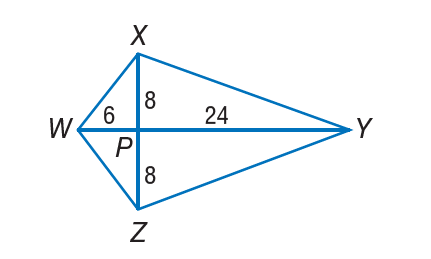Answer the mathemtical geometry problem and directly provide the correct option letter.
Question: If W X Y Z is a kite, find Z Y.
Choices: A: \sqrt { 10 } B: 8 C: 16 D: 8 \sqrt { 10 } D 